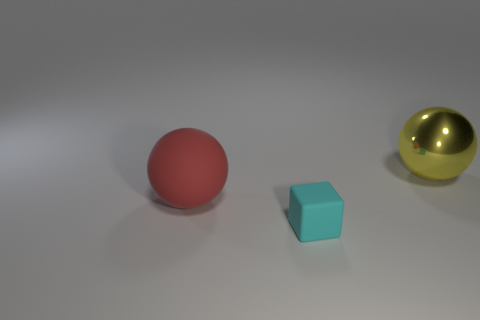How many objects are either things in front of the large red matte object or big green matte things?
Ensure brevity in your answer.  1. There is a large thing that is in front of the big object that is right of the thing in front of the large red thing; what shape is it?
Provide a succinct answer. Sphere. How many large shiny things have the same shape as the big matte object?
Your response must be concise. 1. Do the tiny thing and the red sphere have the same material?
Provide a succinct answer. Yes. How many spheres are left of the large object that is behind the rubber thing left of the matte block?
Offer a terse response. 1. Are there any small cyan objects that have the same material as the large red sphere?
Offer a very short reply. Yes. Is the number of rubber blocks less than the number of gray cylinders?
Provide a short and direct response. No. What is the material of the ball that is on the right side of the matte thing that is in front of the big thing left of the small matte block?
Your answer should be very brief. Metal. Is there a small matte sphere that has the same color as the large metallic object?
Give a very brief answer. No. Is the number of small rubber blocks that are on the right side of the yellow thing less than the number of cyan blocks?
Your answer should be very brief. Yes. 